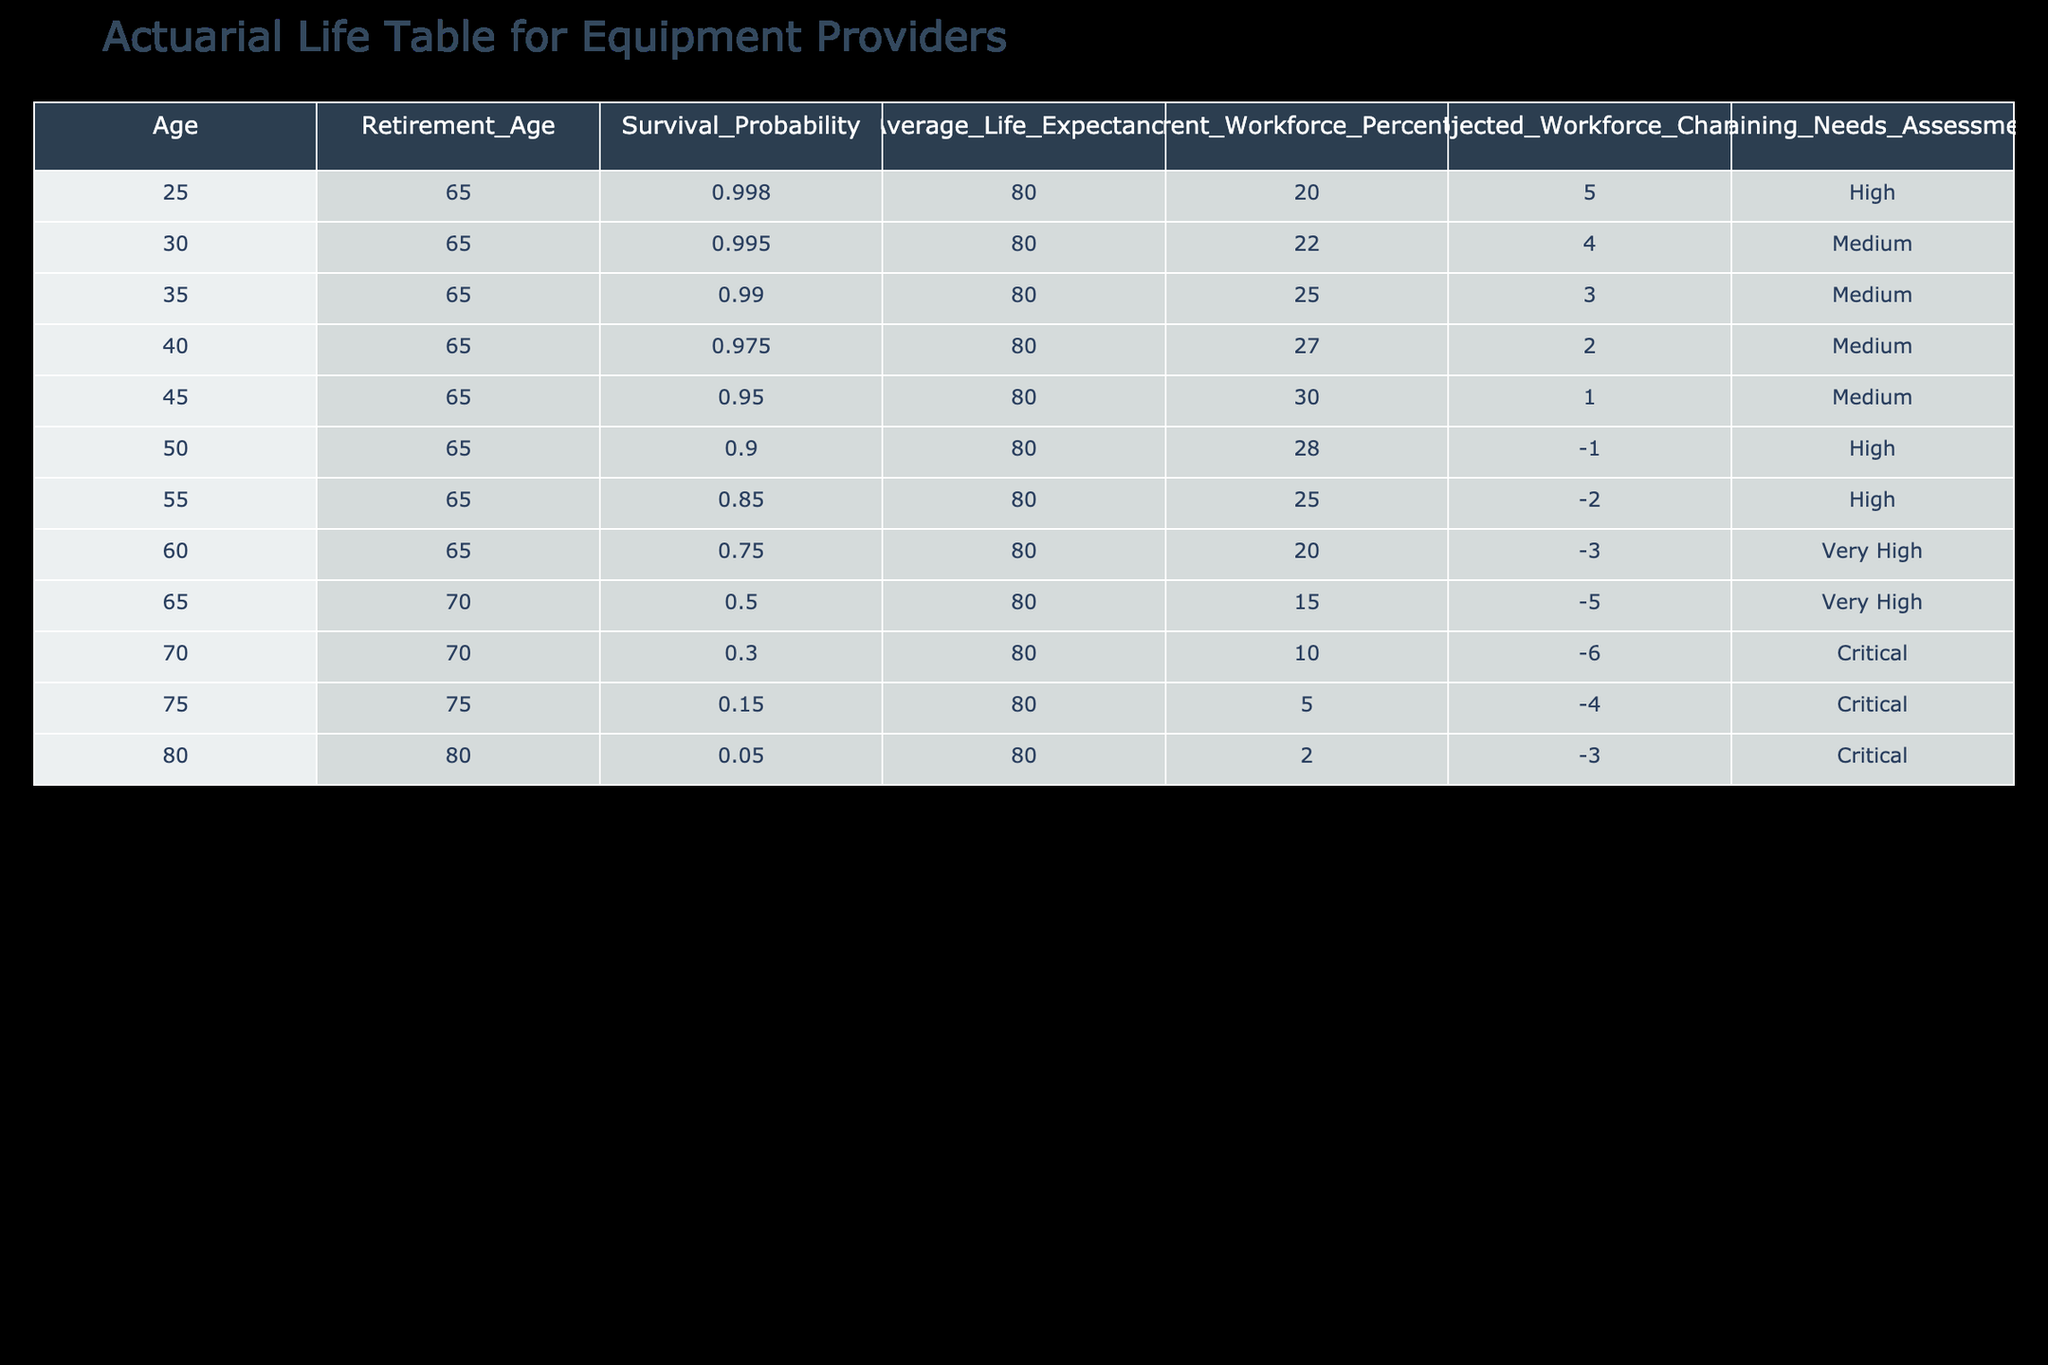What is the survival probability for someone aged 55? In the table, the "Survival_Probability" for age 55 is directly listed as 0.850.
Answer: 0.850 How many people in the current workforce are aged 70? The table shows that the "Current_Workforce_Percentage" for age 70 is 10.
Answer: 10 What is the average retirement age across all ages listed? The retirement ages listed are mainly 65 and 70 with one entry at 75 and one at 80. To find the average, calculate (65*7 + 70*3 + 75 + 80) / 11 = 67.27, rounding gives approximately 67.3.
Answer: 67.3 True or False: The percentage of the current workforce increases with age. By examining the "Current_Workforce_Percentage" column, it initially rises until age 50, then decreases for ages 55 and older, indicating it does not increase with age. Therefore, the statement is false.
Answer: False What is the projected workforce change for individuals aged 65? Referring to the table, the "Projected_Workforce_Change" for age 65 is -5.
Answer: -5 At what age does the workforce change reach a critical level? The table indicates a "Critical" assessment for ages 70, 75, and 80, with at age 70 showing -6, age 75 -4, and age 80 -3. The first age to hit this critical level is 70.
Answer: 70 Calculate the difference in survival probability between age 30 and age 70. The "Survival_Probability" for age 30 is 0.995 and for age 70, it is 0.300. To find the difference, subtract: 0.995 - 0.300 = 0.695.
Answer: 0.695 What training needs assessment is indicated for individuals aged 45? The table specifies "Medium" for the "Training_Needs_Assessment" at age 45.
Answer: Medium Is the average life expectancy consistent across all ages? Yes, the "Average_Life_Expectancy" is consistently stated as 80 across all age rows in the table. Therefore, it is consistent.
Answer: Yes 